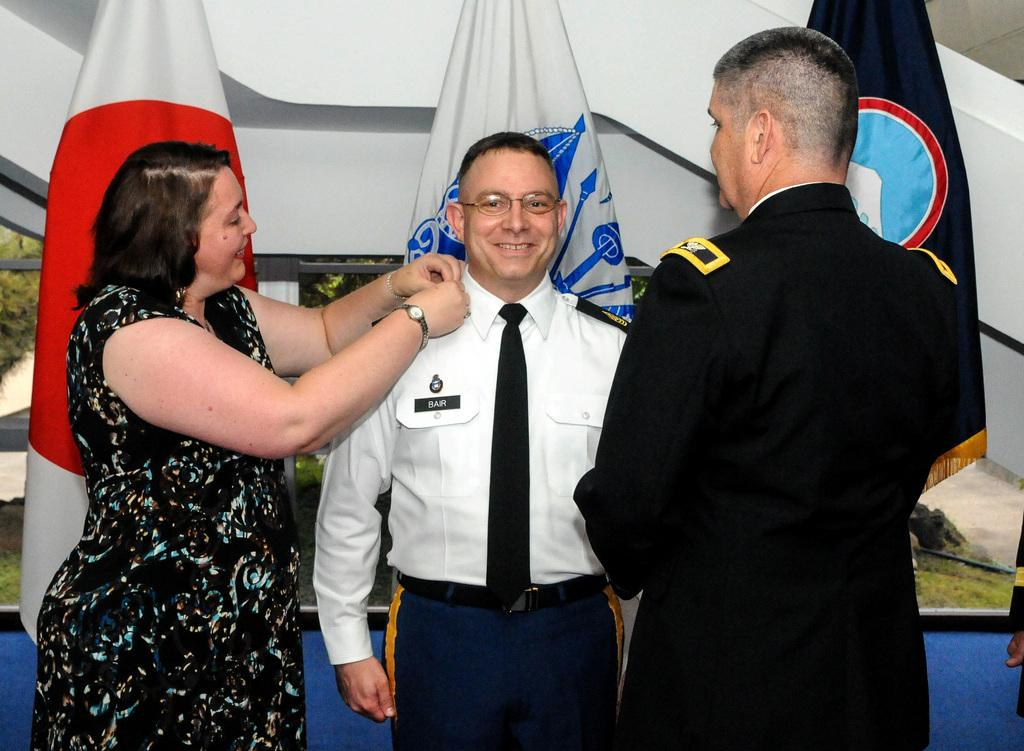How many people are in the image? There are three people in the image: two men and a woman. What are the people in the image doing? The two men and the woman are standing and smiling. What can be seen hanging on poles in the image? There are flags hanging on poles in the image. What is visible in the background of the image? There is a wall in the background of the image. What type of bath can be seen in the image? There is no bath present in the image. Can you describe the beast that is standing next to the woman in the image? There is no beast present in the image; the people in the image are two men and a woman. 